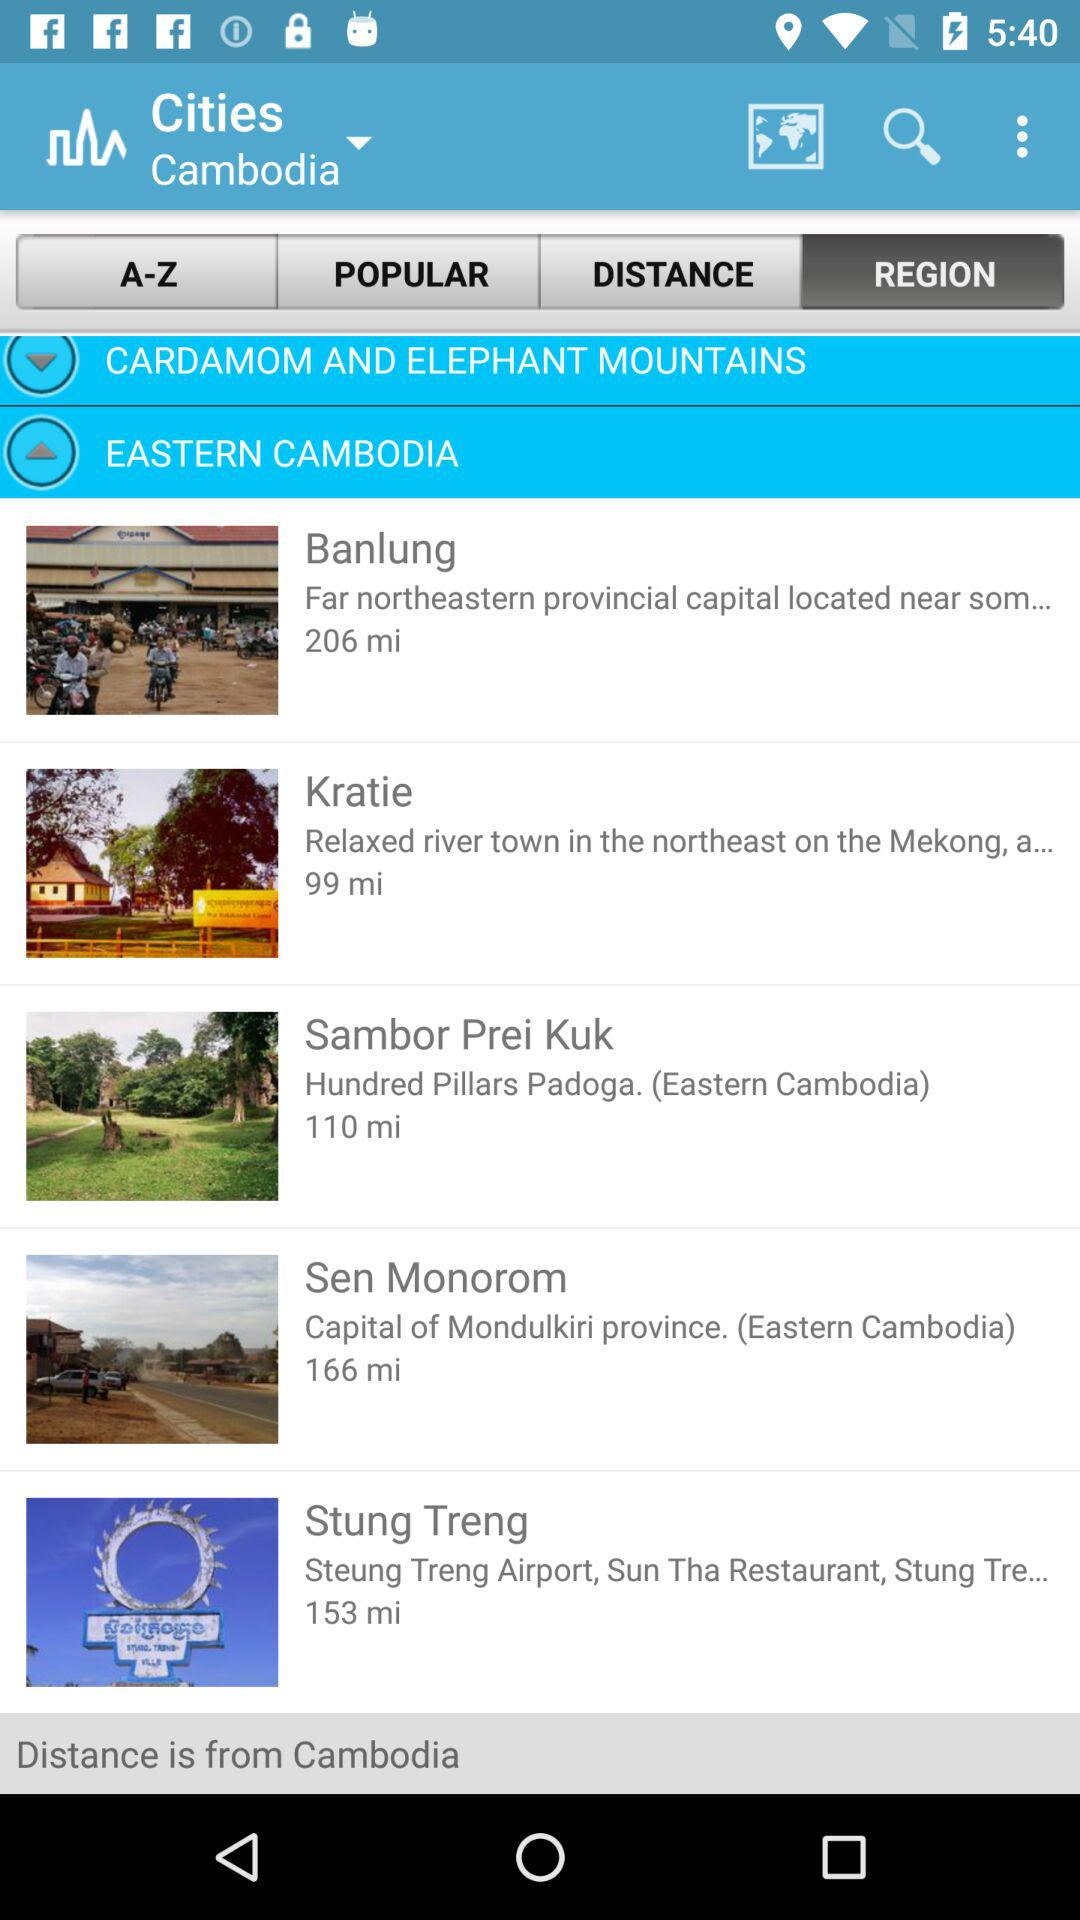Which cities are in western Cambodia?
When the provided information is insufficient, respond with <no answer>. <no answer> 